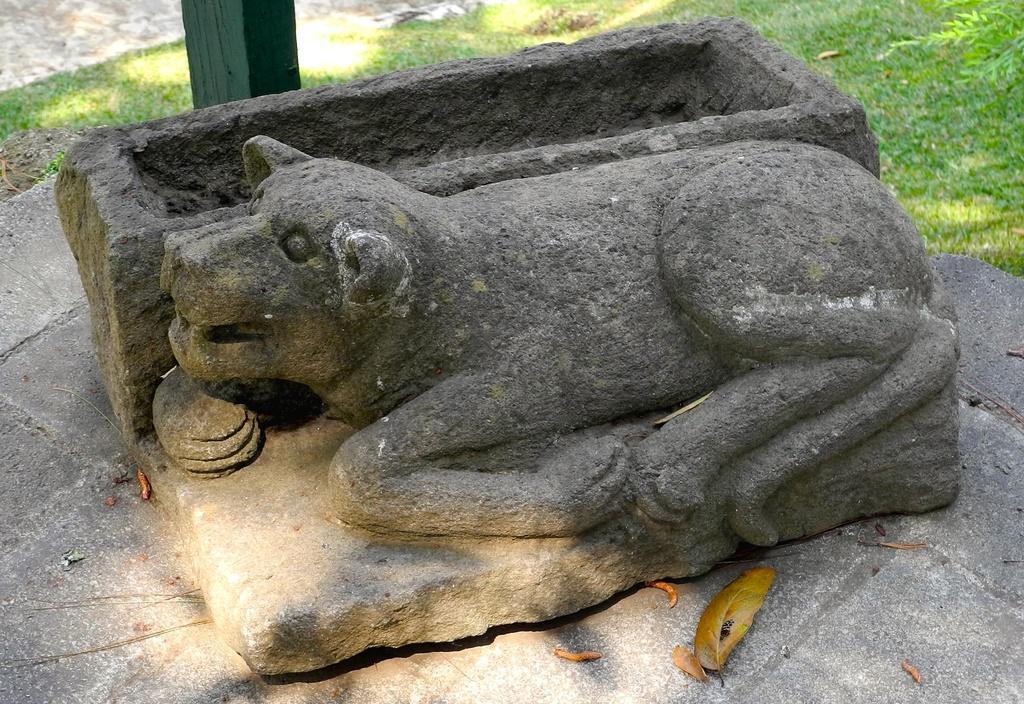Can you describe this image briefly? In this image we can see a sculpture on the ground and we can see a pole and grass in the background. 